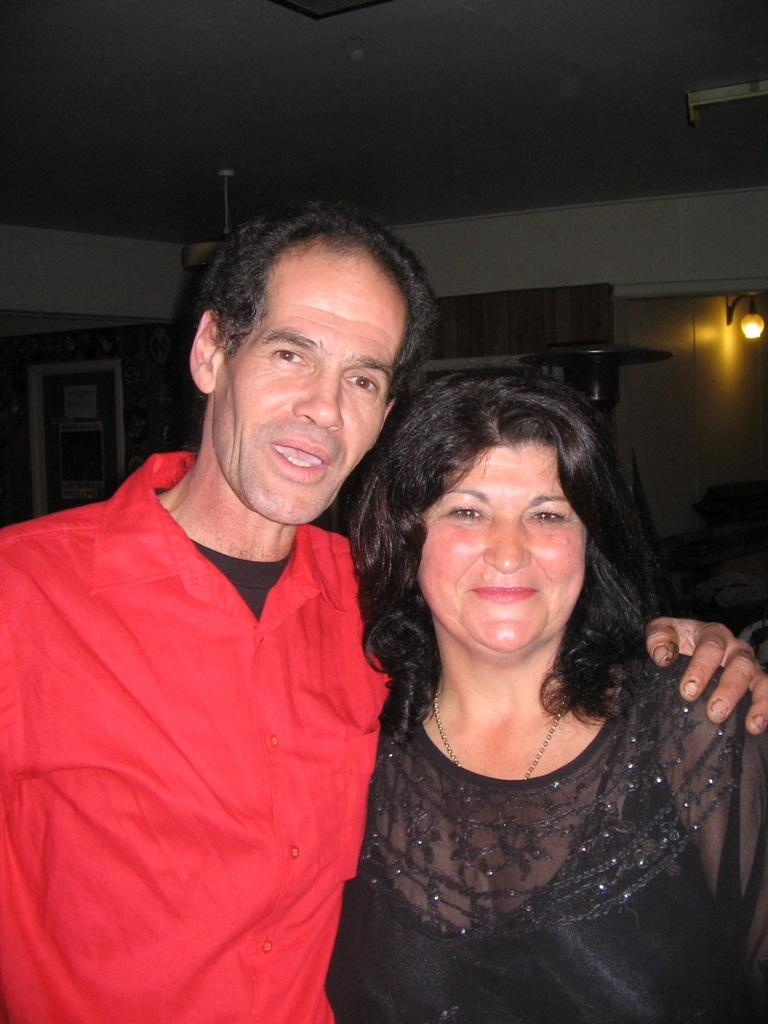How many people are present in the image? There are two people in the image. What is the facial expression of the people in the image? The people are smiling. What can be seen in the background of the image? There is a roof, a wall, and a light in the background of the image. What is the name of the person who just sneezed in the image? There is no indication in the image that anyone has sneezed, and therefore no name can be provided. What suggestion is being made by the person in the image? There is no indication in the image that anyone is making a suggestion, so it cannot be determined from the picture. 